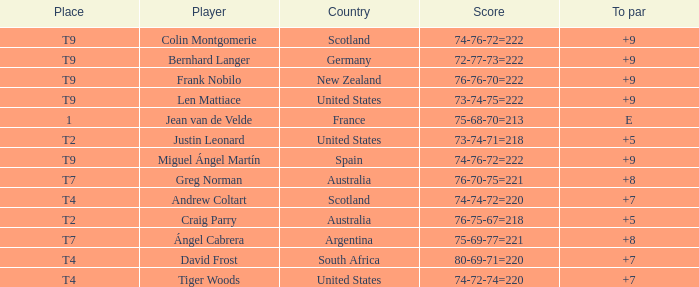Which player from the United States is in a place of T2? Justin Leonard. Parse the full table. {'header': ['Place', 'Player', 'Country', 'Score', 'To par'], 'rows': [['T9', 'Colin Montgomerie', 'Scotland', '74-76-72=222', '+9'], ['T9', 'Bernhard Langer', 'Germany', '72-77-73=222', '+9'], ['T9', 'Frank Nobilo', 'New Zealand', '76-76-70=222', '+9'], ['T9', 'Len Mattiace', 'United States', '73-74-75=222', '+9'], ['1', 'Jean van de Velde', 'France', '75-68-70=213', 'E'], ['T2', 'Justin Leonard', 'United States', '73-74-71=218', '+5'], ['T9', 'Miguel Ángel Martín', 'Spain', '74-76-72=222', '+9'], ['T7', 'Greg Norman', 'Australia', '76-70-75=221', '+8'], ['T4', 'Andrew Coltart', 'Scotland', '74-74-72=220', '+7'], ['T2', 'Craig Parry', 'Australia', '76-75-67=218', '+5'], ['T7', 'Ángel Cabrera', 'Argentina', '75-69-77=221', '+8'], ['T4', 'David Frost', 'South Africa', '80-69-71=220', '+7'], ['T4', 'Tiger Woods', 'United States', '74-72-74=220', '+7']]} 